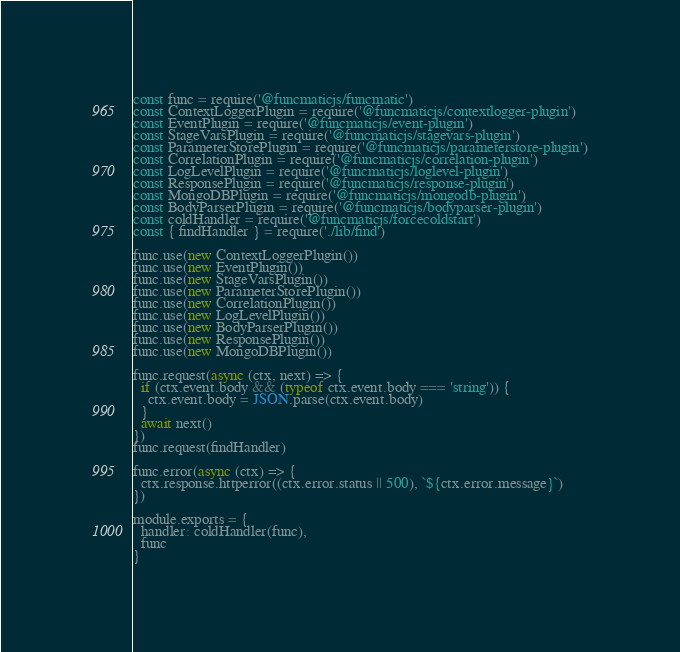Convert code to text. <code><loc_0><loc_0><loc_500><loc_500><_JavaScript_>const func = require('@funcmaticjs/funcmatic')
const ContextLoggerPlugin = require('@funcmaticjs/contextlogger-plugin')
const EventPlugin = require('@funcmaticjs/event-plugin')
const StageVarsPlugin = require('@funcmaticjs/stagevars-plugin')
const ParameterStorePlugin = require('@funcmaticjs/parameterstore-plugin')
const CorrelationPlugin = require('@funcmaticjs/correlation-plugin')
const LogLevelPlugin = require('@funcmaticjs/loglevel-plugin')
const ResponsePlugin = require('@funcmaticjs/response-plugin')
const MongoDBPlugin = require('@funcmaticjs/mongodb-plugin')
const BodyParserPlugin = require('@funcmaticjs/bodyparser-plugin')
const coldHandler = require('@funcmaticjs/forcecoldstart')
const { findHandler } = require('./lib/find')

func.use(new ContextLoggerPlugin())
func.use(new EventPlugin())
func.use(new StageVarsPlugin())
func.use(new ParameterStorePlugin())
func.use(new CorrelationPlugin())
func.use(new LogLevelPlugin())
func.use(new BodyParserPlugin())
func.use(new ResponsePlugin())
func.use(new MongoDBPlugin())

func.request(async (ctx, next) => {
  if (ctx.event.body && (typeof ctx.event.body === 'string')) {
    ctx.event.body = JSON.parse(ctx.event.body)
  }
  await next()
})
func.request(findHandler)

func.error(async (ctx) => {
  ctx.response.httperror((ctx.error.status || 500), `${ctx.error.message}`)
})

module.exports = {
  handler: coldHandler(func),
  func
}


</code> 